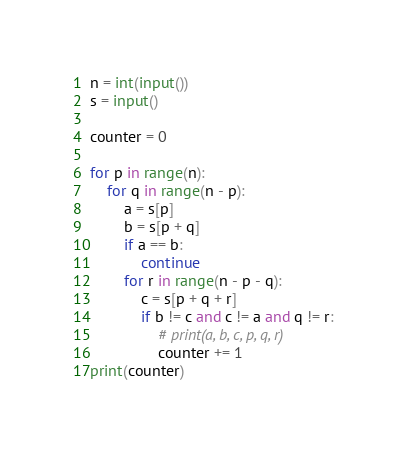Convert code to text. <code><loc_0><loc_0><loc_500><loc_500><_Python_>n = int(input())
s = input()

counter = 0

for p in range(n):
    for q in range(n - p):
        a = s[p]
        b = s[p + q]
        if a == b:
            continue
        for r in range(n - p - q):
            c = s[p + q + r]
            if b != c and c != a and q != r:
                # print(a, b, c, p, q, r)
                counter += 1
print(counter)</code> 